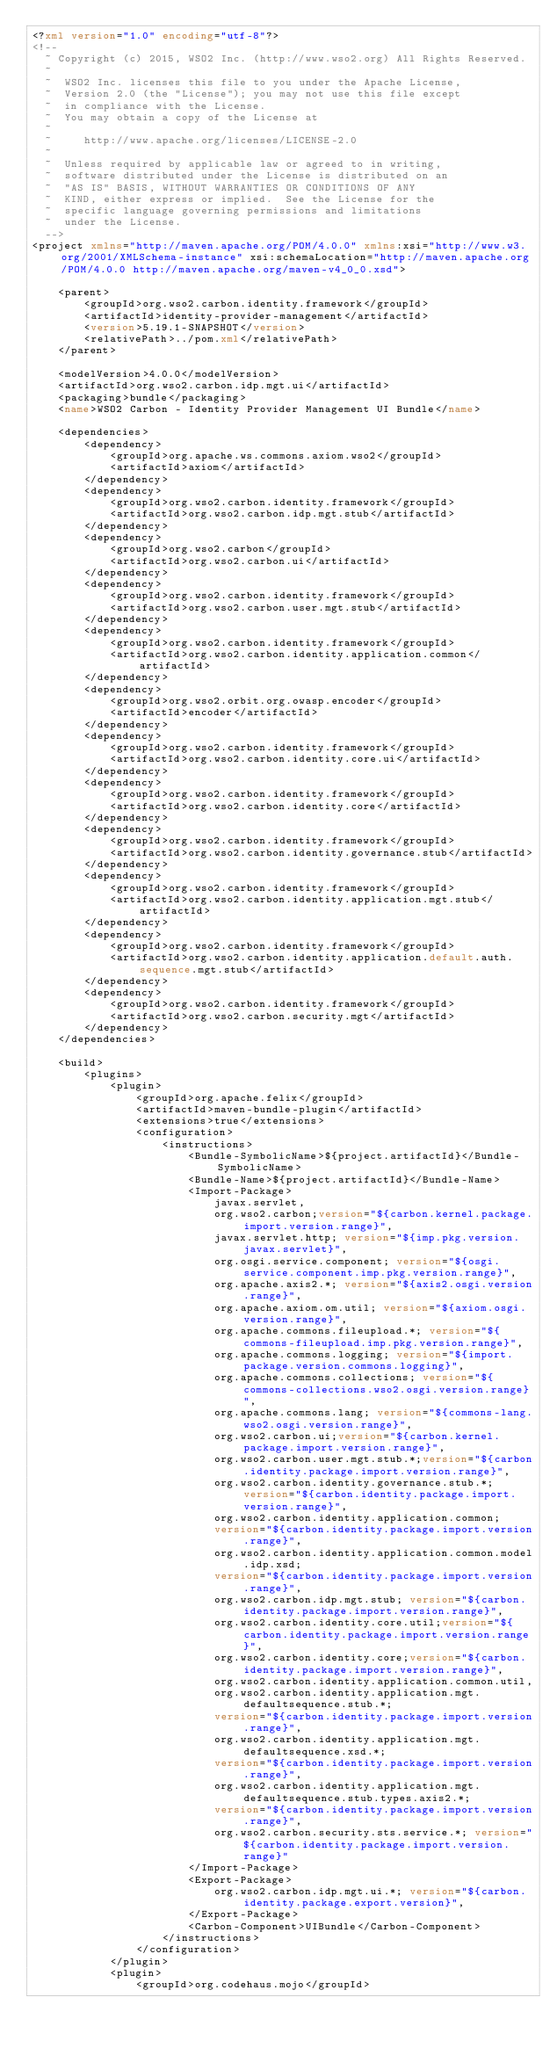Convert code to text. <code><loc_0><loc_0><loc_500><loc_500><_XML_><?xml version="1.0" encoding="utf-8"?>
<!--
  ~ Copyright (c) 2015, WSO2 Inc. (http://www.wso2.org) All Rights Reserved.
  ~
  ~  WSO2 Inc. licenses this file to you under the Apache License,
  ~  Version 2.0 (the "License"); you may not use this file except
  ~  in compliance with the License.
  ~  You may obtain a copy of the License at
  ~
  ~     http://www.apache.org/licenses/LICENSE-2.0
  ~
  ~  Unless required by applicable law or agreed to in writing,
  ~  software distributed under the License is distributed on an
  ~  "AS IS" BASIS, WITHOUT WARRANTIES OR CONDITIONS OF ANY
  ~  KIND, either express or implied.  See the License for the
  ~  specific language governing permissions and limitations
  ~  under the License.
  -->
<project xmlns="http://maven.apache.org/POM/4.0.0" xmlns:xsi="http://www.w3.org/2001/XMLSchema-instance" xsi:schemaLocation="http://maven.apache.org/POM/4.0.0 http://maven.apache.org/maven-v4_0_0.xsd">

    <parent>
        <groupId>org.wso2.carbon.identity.framework</groupId>
        <artifactId>identity-provider-management</artifactId>
        <version>5.19.1-SNAPSHOT</version>
        <relativePath>../pom.xml</relativePath>
    </parent>

    <modelVersion>4.0.0</modelVersion>
    <artifactId>org.wso2.carbon.idp.mgt.ui</artifactId>
    <packaging>bundle</packaging>
    <name>WSO2 Carbon - Identity Provider Management UI Bundle</name>

    <dependencies>
        <dependency>
            <groupId>org.apache.ws.commons.axiom.wso2</groupId>
            <artifactId>axiom</artifactId>
        </dependency>
        <dependency>
            <groupId>org.wso2.carbon.identity.framework</groupId>
            <artifactId>org.wso2.carbon.idp.mgt.stub</artifactId>
        </dependency>
        <dependency>
            <groupId>org.wso2.carbon</groupId>
            <artifactId>org.wso2.carbon.ui</artifactId>
        </dependency>
        <dependency>
            <groupId>org.wso2.carbon.identity.framework</groupId>
            <artifactId>org.wso2.carbon.user.mgt.stub</artifactId>
        </dependency>
        <dependency>
            <groupId>org.wso2.carbon.identity.framework</groupId>
            <artifactId>org.wso2.carbon.identity.application.common</artifactId>
        </dependency>
        <dependency>
            <groupId>org.wso2.orbit.org.owasp.encoder</groupId>
            <artifactId>encoder</artifactId>
        </dependency>
        <dependency>
            <groupId>org.wso2.carbon.identity.framework</groupId>
            <artifactId>org.wso2.carbon.identity.core.ui</artifactId>
        </dependency>
        <dependency>
            <groupId>org.wso2.carbon.identity.framework</groupId>
            <artifactId>org.wso2.carbon.identity.core</artifactId>
        </dependency>
        <dependency>
            <groupId>org.wso2.carbon.identity.framework</groupId>
            <artifactId>org.wso2.carbon.identity.governance.stub</artifactId>
        </dependency>
        <dependency>
            <groupId>org.wso2.carbon.identity.framework</groupId>
            <artifactId>org.wso2.carbon.identity.application.mgt.stub</artifactId>
        </dependency>
        <dependency>
            <groupId>org.wso2.carbon.identity.framework</groupId>
            <artifactId>org.wso2.carbon.identity.application.default.auth.sequence.mgt.stub</artifactId>
        </dependency>
        <dependency>
            <groupId>org.wso2.carbon.identity.framework</groupId>
            <artifactId>org.wso2.carbon.security.mgt</artifactId>
        </dependency>
    </dependencies>

    <build>
        <plugins>
            <plugin>
                <groupId>org.apache.felix</groupId>
                <artifactId>maven-bundle-plugin</artifactId>
                <extensions>true</extensions>
                <configuration>
                    <instructions>
                        <Bundle-SymbolicName>${project.artifactId}</Bundle-SymbolicName>
                        <Bundle-Name>${project.artifactId}</Bundle-Name>
                        <Import-Package>
                            javax.servlet,
                            org.wso2.carbon;version="${carbon.kernel.package.import.version.range}",
                            javax.servlet.http; version="${imp.pkg.version.javax.servlet}",
                            org.osgi.service.component; version="${osgi.service.component.imp.pkg.version.range}",
                            org.apache.axis2.*; version="${axis2.osgi.version.range}",
                            org.apache.axiom.om.util; version="${axiom.osgi.version.range}",
                            org.apache.commons.fileupload.*; version="${commons-fileupload.imp.pkg.version.range}",
                            org.apache.commons.logging; version="${import.package.version.commons.logging}",
                            org.apache.commons.collections; version="${commons-collections.wso2.osgi.version.range}",
                            org.apache.commons.lang; version="${commons-lang.wso2.osgi.version.range}",
                            org.wso2.carbon.ui;version="${carbon.kernel.package.import.version.range}",
                            org.wso2.carbon.user.mgt.stub.*;version="${carbon.identity.package.import.version.range}",
                            org.wso2.carbon.identity.governance.stub.*;version="${carbon.identity.package.import.version.range}",
                            org.wso2.carbon.identity.application.common;
                            version="${carbon.identity.package.import.version.range}",
                            org.wso2.carbon.identity.application.common.model.idp.xsd;
                            version="${carbon.identity.package.import.version.range}",
                            org.wso2.carbon.idp.mgt.stub; version="${carbon.identity.package.import.version.range}",
                            org.wso2.carbon.identity.core.util;version="${carbon.identity.package.import.version.range}",
                            org.wso2.carbon.identity.core;version="${carbon.identity.package.import.version.range}",
                            org.wso2.carbon.identity.application.common.util,
                            org.wso2.carbon.identity.application.mgt.defaultsequence.stub.*;
                            version="${carbon.identity.package.import.version.range}",
                            org.wso2.carbon.identity.application.mgt.defaultsequence.xsd.*;
                            version="${carbon.identity.package.import.version.range}",
                            org.wso2.carbon.identity.application.mgt.defaultsequence.stub.types.axis2.*;
                            version="${carbon.identity.package.import.version.range}",
                            org.wso2.carbon.security.sts.service.*; version="${carbon.identity.package.import.version.range}"
                        </Import-Package>
                        <Export-Package>
                            org.wso2.carbon.idp.mgt.ui.*; version="${carbon.identity.package.export.version}",
                        </Export-Package>
                        <Carbon-Component>UIBundle</Carbon-Component>
                    </instructions>
                </configuration>
            </plugin>
            <plugin>
                <groupId>org.codehaus.mojo</groupId></code> 